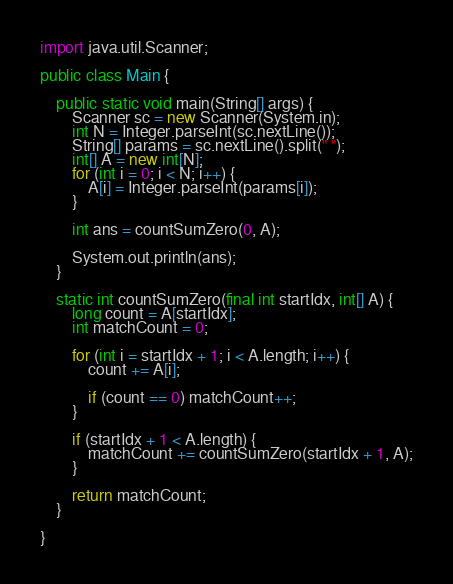Convert code to text. <code><loc_0><loc_0><loc_500><loc_500><_Java_>import java.util.Scanner;

public class Main {

	public static void main(String[] args) {
		Scanner sc = new Scanner(System.in);
		int N = Integer.parseInt(sc.nextLine());
		String[] params = sc.nextLine().split(" ");
		int[] A = new int[N];
		for (int i = 0; i < N; i++) {
			A[i] = Integer.parseInt(params[i]);
		}
		
		int ans = countSumZero(0, A);
		
		System.out.println(ans);
	}
	
	static int countSumZero(final int startIdx, int[] A) {
		long count = A[startIdx];
		int matchCount = 0;
		
		for (int i = startIdx + 1; i < A.length; i++) {
			count += A[i];
			
			if (count == 0) matchCount++;
		}
		
		if (startIdx + 1 < A.length) {
			matchCount += countSumZero(startIdx + 1, A);
		}
		
		return matchCount;
	}
 
}</code> 